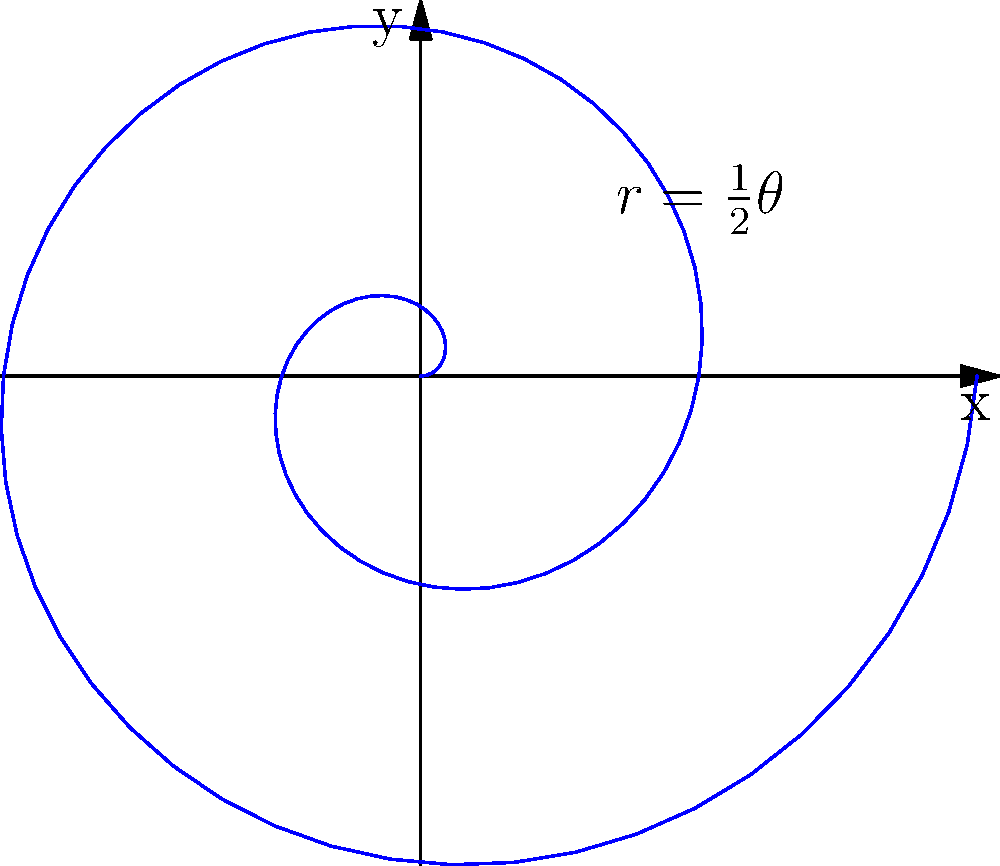Consider the spiral curve defined by the polar equation $r = \frac{1}{2}\theta$, where $r$ is the radius and $\theta$ is the angle in radians. Calculate the arc length of this spiral from $\theta = 0$ to $\theta = 4\pi$. To find the arc length of a curve defined in polar coordinates, we use the formula:

$$ L = \int_a^b \sqrt{r^2 + \left(\frac{dr}{d\theta}\right)^2} \, d\theta $$

Let's follow these steps:

1) First, we need to find $\frac{dr}{d\theta}$:
   $r = \frac{1}{2}\theta$, so $\frac{dr}{d\theta} = \frac{1}{2}$

2) Now, let's substitute these into the formula:
   $$ L = \int_0^{4\pi} \sqrt{\left(\frac{1}{2}\theta\right)^2 + \left(\frac{1}{2}\right)^2} \, d\theta $$

3) Simplify inside the square root:
   $$ L = \int_0^{4\pi} \sqrt{\frac{1}{4}\theta^2 + \frac{1}{4}} \, d\theta $$
   $$ L = \int_0^{4\pi} \frac{1}{2}\sqrt{\theta^2 + 1} \, d\theta $$

4) This integral can be solved using the substitution $u = \theta^2 + 1$:
   $$ L = \frac{1}{4} \left[ \theta\sqrt{\theta^2 + 1} + \ln(\theta + \sqrt{\theta^2 + 1}) \right]_0^{4\pi} $$

5) Evaluate at the limits:
   $$ L = \frac{1}{4} \left[ 4\pi\sqrt{16\pi^2 + 1} + \ln(4\pi + \sqrt{16\pi^2 + 1}) - (0 + \ln(1)) \right] $$

6) Simplify:
   $$ L = \pi\sqrt{16\pi^2 + 1} + \frac{1}{4}\ln(4\pi + \sqrt{16\pi^2 + 1}) $$
Answer: $\pi\sqrt{16\pi^2 + 1} + \frac{1}{4}\ln(4\pi + \sqrt{16\pi^2 + 1})$ 